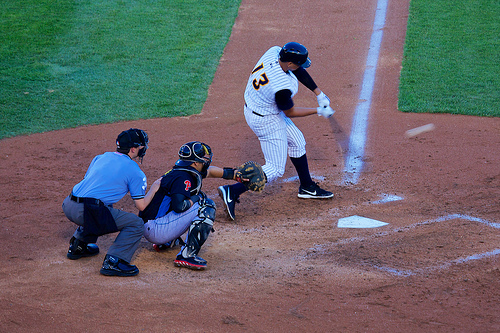Who is wearing a belt? The player at bat wears a belt, part of the standard baseball attire. 